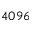<formula> <loc_0><loc_0><loc_500><loc_500>4 0 9 6</formula> 